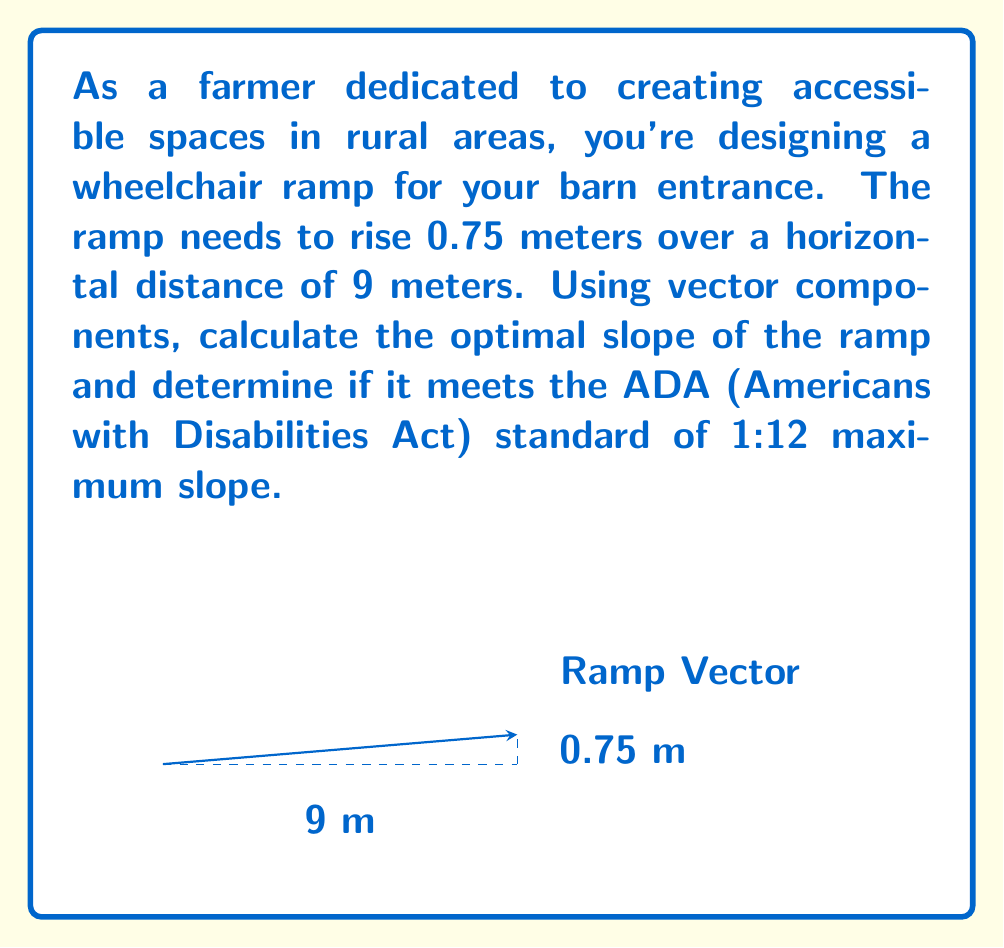Could you help me with this problem? Let's approach this step-by-step:

1) The ramp can be represented as a vector $\vec{r}$ with horizontal (x) and vertical (y) components:
   $$\vec{r} = (9, 0.75)$$

2) The slope of the ramp is the ratio of the vertical rise to the horizontal run, which can be calculated using the vector components:
   $$\text{Slope} = \frac{y \text{ component}}{x \text{ component}} = \frac{0.75}{9}$$

3) Simplify this fraction:
   $$\frac{0.75}{9} = \frac{1}{12}$$

4) To express this as a ratio, we write it as 1:12.

5) The ADA standard for maximum slope is 1:12, which means 1 unit of vertical rise for every 12 units of horizontal run.

6) Compare our result (1:12) to the ADA standard (1:12 maximum):
   Our ramp slope exactly meets the ADA standard, providing the maximum allowable slope for accessibility.
Answer: Slope = 1:12; meets ADA standard 